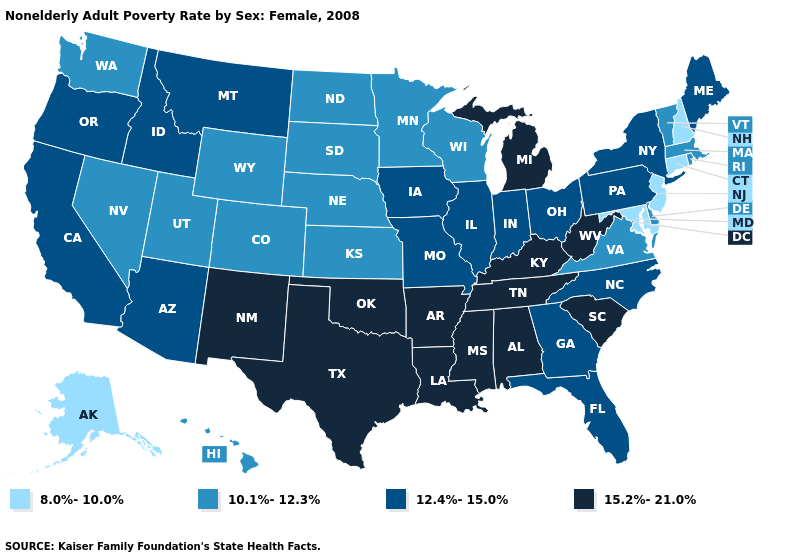Name the states that have a value in the range 12.4%-15.0%?
Concise answer only. Arizona, California, Florida, Georgia, Idaho, Illinois, Indiana, Iowa, Maine, Missouri, Montana, New York, North Carolina, Ohio, Oregon, Pennsylvania. What is the value of New York?
Be succinct. 12.4%-15.0%. Among the states that border Oklahoma , does Arkansas have the highest value?
Short answer required. Yes. Is the legend a continuous bar?
Answer briefly. No. What is the value of South Carolina?
Short answer required. 15.2%-21.0%. Name the states that have a value in the range 8.0%-10.0%?
Short answer required. Alaska, Connecticut, Maryland, New Hampshire, New Jersey. What is the value of Idaho?
Write a very short answer. 12.4%-15.0%. What is the lowest value in the USA?
Keep it brief. 8.0%-10.0%. Is the legend a continuous bar?
Write a very short answer. No. Name the states that have a value in the range 8.0%-10.0%?
Quick response, please. Alaska, Connecticut, Maryland, New Hampshire, New Jersey. What is the value of New Hampshire?
Quick response, please. 8.0%-10.0%. What is the value of West Virginia?
Be succinct. 15.2%-21.0%. What is the lowest value in states that border Delaware?
Quick response, please. 8.0%-10.0%. What is the value of New York?
Give a very brief answer. 12.4%-15.0%. Name the states that have a value in the range 10.1%-12.3%?
Concise answer only. Colorado, Delaware, Hawaii, Kansas, Massachusetts, Minnesota, Nebraska, Nevada, North Dakota, Rhode Island, South Dakota, Utah, Vermont, Virginia, Washington, Wisconsin, Wyoming. 